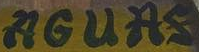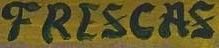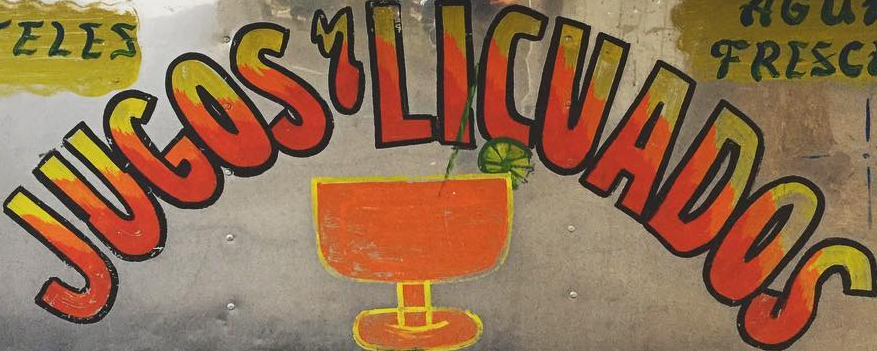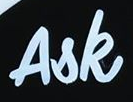Identify the words shown in these images in order, separated by a semicolon. AGUAS; FRESCAS; JUGOS'LICUADOS; Ask 